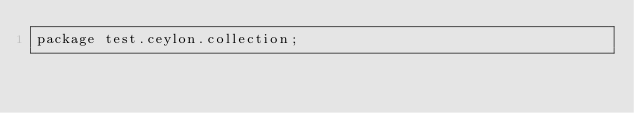Convert code to text. <code><loc_0><loc_0><loc_500><loc_500><_Ceylon_>package test.ceylon.collection;
</code> 